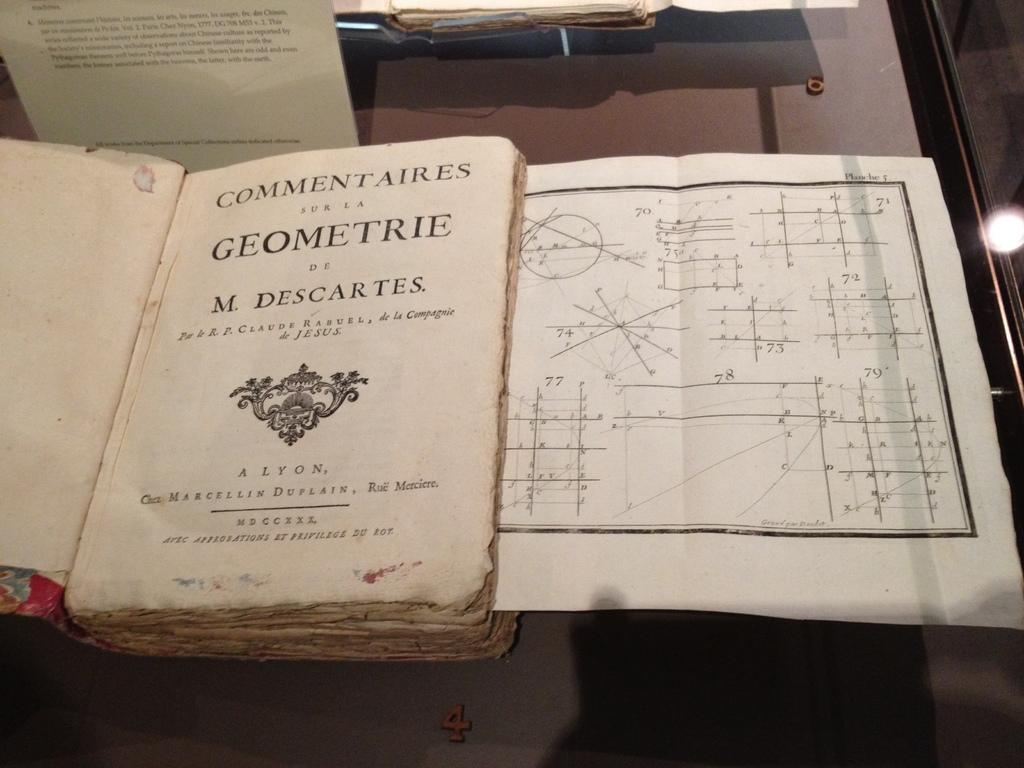<image>
Offer a succinct explanation of the picture presented. A book tilted Commetaires and La Geometrie M. Descartes. 